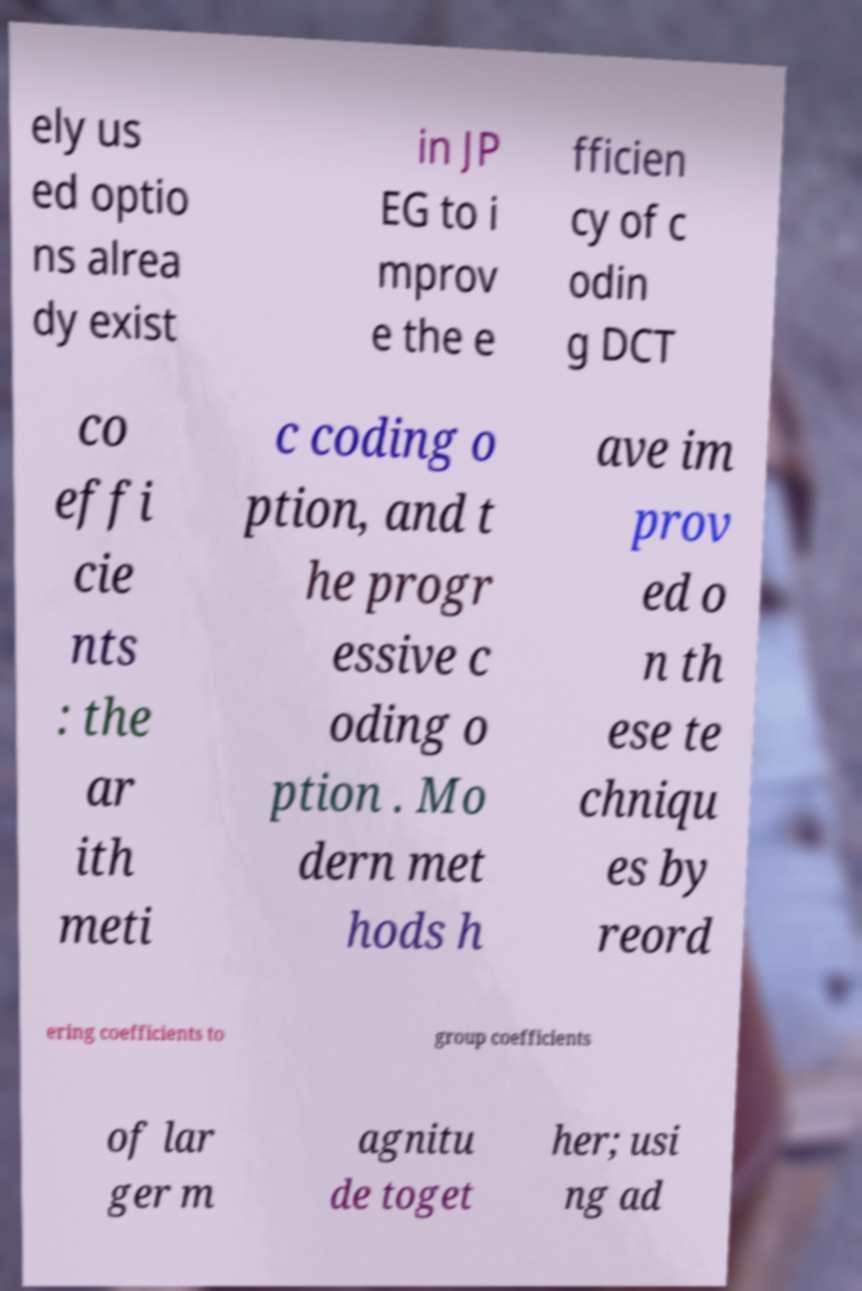Could you extract and type out the text from this image? ely us ed optio ns alrea dy exist in JP EG to i mprov e the e fficien cy of c odin g DCT co effi cie nts : the ar ith meti c coding o ption, and t he progr essive c oding o ption . Mo dern met hods h ave im prov ed o n th ese te chniqu es by reord ering coefficients to group coefficients of lar ger m agnitu de toget her; usi ng ad 